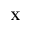<formula> <loc_0><loc_0><loc_500><loc_500>X</formula> 